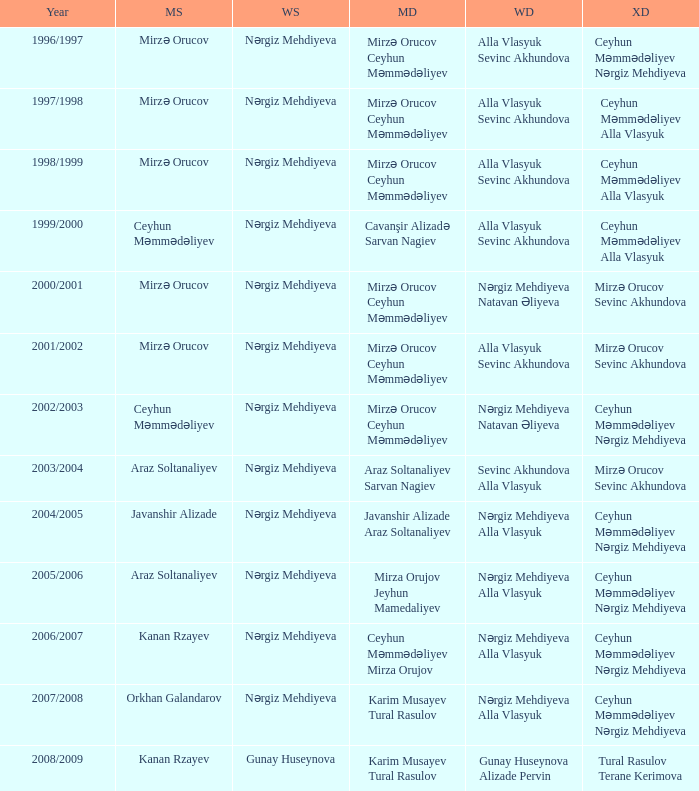Who are all the womens doubles for the year 2008/2009? Gunay Huseynova Alizade Pervin. 